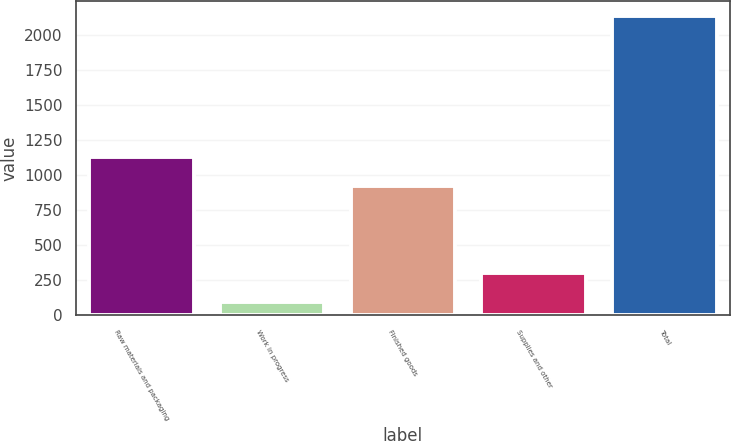Convert chart. <chart><loc_0><loc_0><loc_500><loc_500><bar_chart><fcel>Raw materials and packaging<fcel>Work in progress<fcel>Finished goods<fcel>Supplies and other<fcel>Total<nl><fcel>1126.92<fcel>97.4<fcel>923.6<fcel>300.72<fcel>2130.6<nl></chart> 